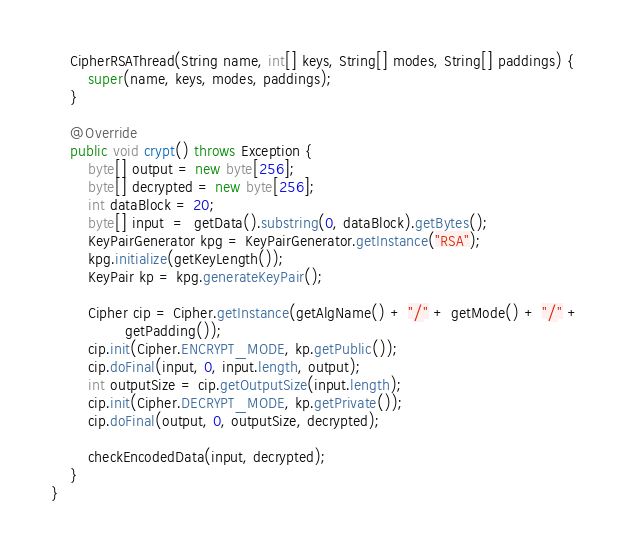<code> <loc_0><loc_0><loc_500><loc_500><_Java_>
    CipherRSAThread(String name, int[] keys, String[] modes, String[] paddings) {
        super(name, keys, modes, paddings);
    }

    @Override
    public void crypt() throws Exception {
        byte[] output = new byte[256];
        byte[] decrypted = new byte[256];
        int dataBlock = 20;
        byte[] input  =  getData().substring(0, dataBlock).getBytes();
        KeyPairGenerator kpg = KeyPairGenerator.getInstance("RSA");
        kpg.initialize(getKeyLength());
        KeyPair kp = kpg.generateKeyPair();

        Cipher cip = Cipher.getInstance(getAlgName() + "/" + getMode() + "/" +
                getPadding());
        cip.init(Cipher.ENCRYPT_MODE, kp.getPublic());
        cip.doFinal(input, 0, input.length, output);
        int outputSize = cip.getOutputSize(input.length);
        cip.init(Cipher.DECRYPT_MODE, kp.getPrivate());
        cip.doFinal(output, 0, outputSize, decrypted);

        checkEncodedData(input, decrypted);
    }
}
</code> 